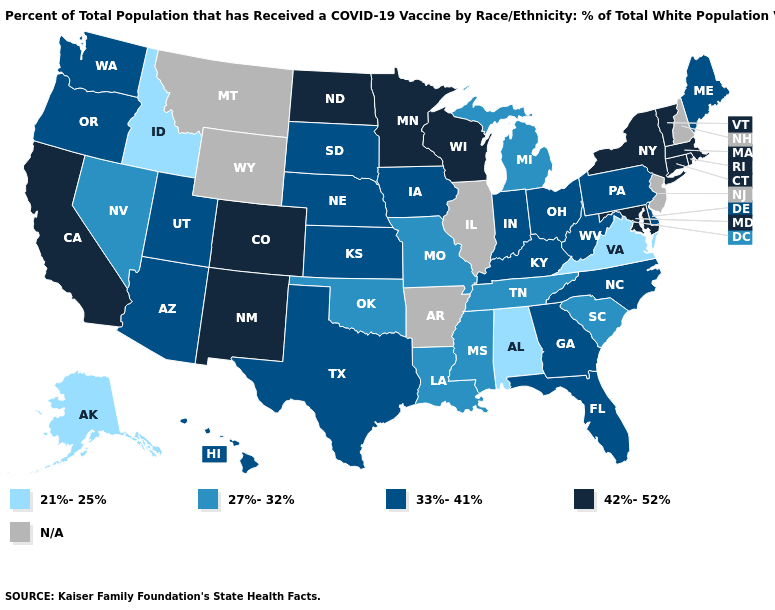Name the states that have a value in the range 21%-25%?
Concise answer only. Alabama, Alaska, Idaho, Virginia. Name the states that have a value in the range 21%-25%?
Be succinct. Alabama, Alaska, Idaho, Virginia. What is the value of Connecticut?
Write a very short answer. 42%-52%. Does Alabama have the highest value in the USA?
Give a very brief answer. No. Name the states that have a value in the range 21%-25%?
Answer briefly. Alabama, Alaska, Idaho, Virginia. Among the states that border Florida , does Alabama have the highest value?
Quick response, please. No. Is the legend a continuous bar?
Answer briefly. No. Among the states that border Illinois , which have the lowest value?
Answer briefly. Missouri. Name the states that have a value in the range N/A?
Quick response, please. Arkansas, Illinois, Montana, New Hampshire, New Jersey, Wyoming. What is the value of Georgia?
Be succinct. 33%-41%. Name the states that have a value in the range N/A?
Be succinct. Arkansas, Illinois, Montana, New Hampshire, New Jersey, Wyoming. Among the states that border Florida , does Georgia have the highest value?
Answer briefly. Yes. Which states have the highest value in the USA?
Keep it brief. California, Colorado, Connecticut, Maryland, Massachusetts, Minnesota, New Mexico, New York, North Dakota, Rhode Island, Vermont, Wisconsin. What is the value of Nebraska?
Answer briefly. 33%-41%. What is the value of California?
Give a very brief answer. 42%-52%. 